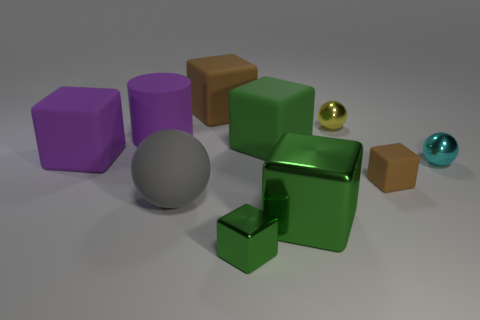Does the tiny shiny cube have the same color as the big metal block?
Offer a terse response. Yes. There is a green cube that is behind the small metallic block and in front of the gray thing; how big is it?
Make the answer very short. Large. There is a large block that is the same color as the cylinder; what is its material?
Your answer should be compact. Rubber. Is the size of the matte block that is in front of the cyan ball the same as the large purple cylinder?
Ensure brevity in your answer.  No. What number of small objects are either green things or green matte things?
Ensure brevity in your answer.  1. Is there a large cylinder of the same color as the big metallic block?
Give a very brief answer. No. What is the shape of the cyan thing that is the same size as the yellow ball?
Offer a very short reply. Sphere. Do the shiny block behind the tiny green metallic thing and the big cylinder have the same color?
Your answer should be compact. No. How many objects are rubber blocks that are behind the matte cylinder or large yellow shiny spheres?
Make the answer very short. 1. Is the number of objects on the left side of the small cyan thing greater than the number of green metal things that are to the right of the tiny green object?
Your answer should be compact. Yes. 